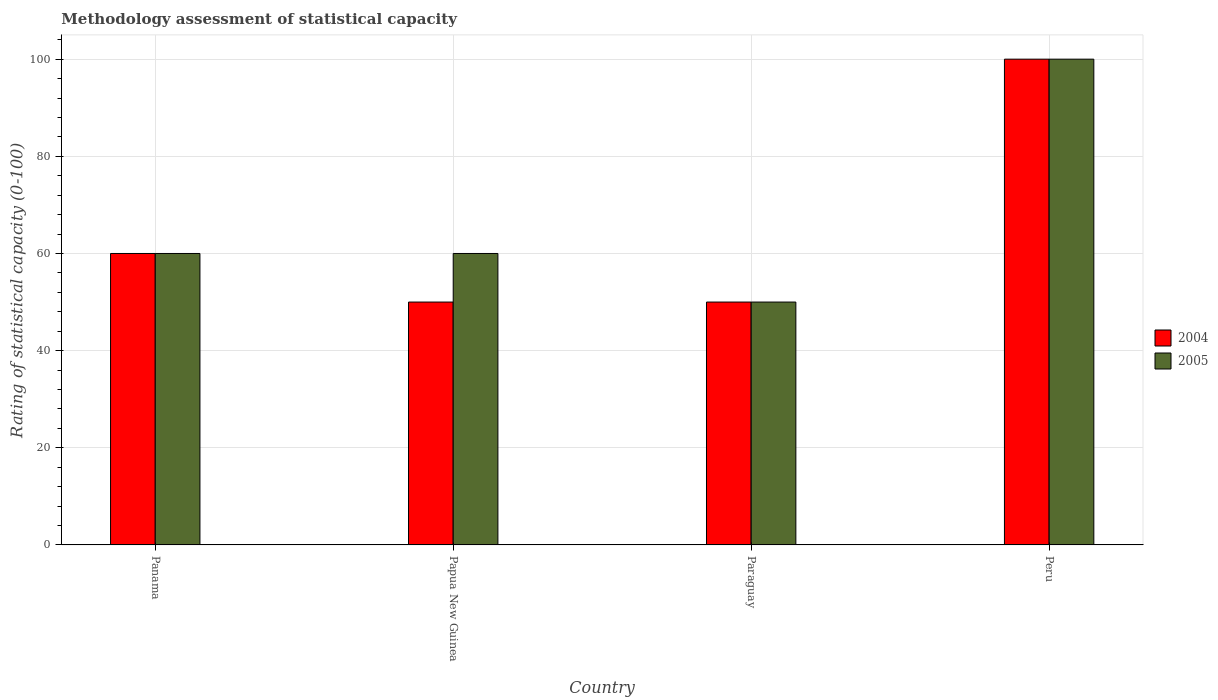How many groups of bars are there?
Keep it short and to the point. 4. Are the number of bars per tick equal to the number of legend labels?
Provide a succinct answer. Yes. How many bars are there on the 4th tick from the left?
Make the answer very short. 2. What is the label of the 3rd group of bars from the left?
Provide a short and direct response. Paraguay. In how many cases, is the number of bars for a given country not equal to the number of legend labels?
Offer a terse response. 0. What is the rating of statistical capacity in 2005 in Panama?
Provide a succinct answer. 60. In which country was the rating of statistical capacity in 2005 maximum?
Your answer should be very brief. Peru. In which country was the rating of statistical capacity in 2004 minimum?
Your answer should be compact. Papua New Guinea. What is the total rating of statistical capacity in 2005 in the graph?
Your answer should be compact. 270. What is the difference between the rating of statistical capacity in 2005 in Paraguay and the rating of statistical capacity in 2004 in Panama?
Your response must be concise. -10. What is the average rating of statistical capacity in 2005 per country?
Offer a very short reply. 67.5. In how many countries, is the rating of statistical capacity in 2005 greater than 4?
Provide a succinct answer. 4. Is the difference between the rating of statistical capacity in 2004 in Paraguay and Peru greater than the difference between the rating of statistical capacity in 2005 in Paraguay and Peru?
Provide a short and direct response. No. What is the difference between the highest and the lowest rating of statistical capacity in 2005?
Your response must be concise. 50. In how many countries, is the rating of statistical capacity in 2005 greater than the average rating of statistical capacity in 2005 taken over all countries?
Ensure brevity in your answer.  1. Is the sum of the rating of statistical capacity in 2005 in Panama and Paraguay greater than the maximum rating of statistical capacity in 2004 across all countries?
Your answer should be compact. Yes. What does the 2nd bar from the right in Peru represents?
Provide a succinct answer. 2004. What is the difference between two consecutive major ticks on the Y-axis?
Your response must be concise. 20. Are the values on the major ticks of Y-axis written in scientific E-notation?
Keep it short and to the point. No. Does the graph contain any zero values?
Provide a succinct answer. No. How many legend labels are there?
Your response must be concise. 2. What is the title of the graph?
Provide a short and direct response. Methodology assessment of statistical capacity. Does "2003" appear as one of the legend labels in the graph?
Your answer should be very brief. No. What is the label or title of the X-axis?
Provide a succinct answer. Country. What is the label or title of the Y-axis?
Provide a short and direct response. Rating of statistical capacity (0-100). What is the Rating of statistical capacity (0-100) of 2004 in Panama?
Your answer should be compact. 60. What is the Rating of statistical capacity (0-100) of 2004 in Papua New Guinea?
Provide a succinct answer. 50. Across all countries, what is the maximum Rating of statistical capacity (0-100) of 2005?
Offer a terse response. 100. What is the total Rating of statistical capacity (0-100) in 2004 in the graph?
Provide a short and direct response. 260. What is the total Rating of statistical capacity (0-100) in 2005 in the graph?
Give a very brief answer. 270. What is the difference between the Rating of statistical capacity (0-100) of 2004 in Panama and that in Peru?
Your answer should be compact. -40. What is the difference between the Rating of statistical capacity (0-100) of 2005 in Panama and that in Peru?
Provide a short and direct response. -40. What is the difference between the Rating of statistical capacity (0-100) of 2004 in Papua New Guinea and that in Paraguay?
Ensure brevity in your answer.  0. What is the difference between the Rating of statistical capacity (0-100) in 2005 in Papua New Guinea and that in Peru?
Your response must be concise. -40. What is the difference between the Rating of statistical capacity (0-100) in 2004 in Panama and the Rating of statistical capacity (0-100) in 2005 in Paraguay?
Make the answer very short. 10. What is the difference between the Rating of statistical capacity (0-100) in 2004 in Panama and the Rating of statistical capacity (0-100) in 2005 in Peru?
Your answer should be compact. -40. What is the difference between the Rating of statistical capacity (0-100) of 2004 in Papua New Guinea and the Rating of statistical capacity (0-100) of 2005 in Paraguay?
Make the answer very short. 0. What is the difference between the Rating of statistical capacity (0-100) in 2004 in Papua New Guinea and the Rating of statistical capacity (0-100) in 2005 in Peru?
Give a very brief answer. -50. What is the difference between the Rating of statistical capacity (0-100) in 2004 in Paraguay and the Rating of statistical capacity (0-100) in 2005 in Peru?
Keep it short and to the point. -50. What is the average Rating of statistical capacity (0-100) in 2005 per country?
Offer a terse response. 67.5. What is the difference between the Rating of statistical capacity (0-100) in 2004 and Rating of statistical capacity (0-100) in 2005 in Panama?
Your answer should be very brief. 0. What is the difference between the Rating of statistical capacity (0-100) of 2004 and Rating of statistical capacity (0-100) of 2005 in Papua New Guinea?
Give a very brief answer. -10. What is the difference between the Rating of statistical capacity (0-100) of 2004 and Rating of statistical capacity (0-100) of 2005 in Paraguay?
Your response must be concise. 0. What is the ratio of the Rating of statistical capacity (0-100) in 2004 in Papua New Guinea to that in Paraguay?
Offer a terse response. 1. What is the ratio of the Rating of statistical capacity (0-100) in 2005 in Papua New Guinea to that in Paraguay?
Make the answer very short. 1.2. What is the ratio of the Rating of statistical capacity (0-100) in 2004 in Papua New Guinea to that in Peru?
Your response must be concise. 0.5. What is the ratio of the Rating of statistical capacity (0-100) in 2005 in Papua New Guinea to that in Peru?
Make the answer very short. 0.6. What is the ratio of the Rating of statistical capacity (0-100) of 2005 in Paraguay to that in Peru?
Offer a very short reply. 0.5. What is the difference between the highest and the second highest Rating of statistical capacity (0-100) of 2004?
Your response must be concise. 40. What is the difference between the highest and the lowest Rating of statistical capacity (0-100) of 2004?
Offer a terse response. 50. What is the difference between the highest and the lowest Rating of statistical capacity (0-100) in 2005?
Ensure brevity in your answer.  50. 